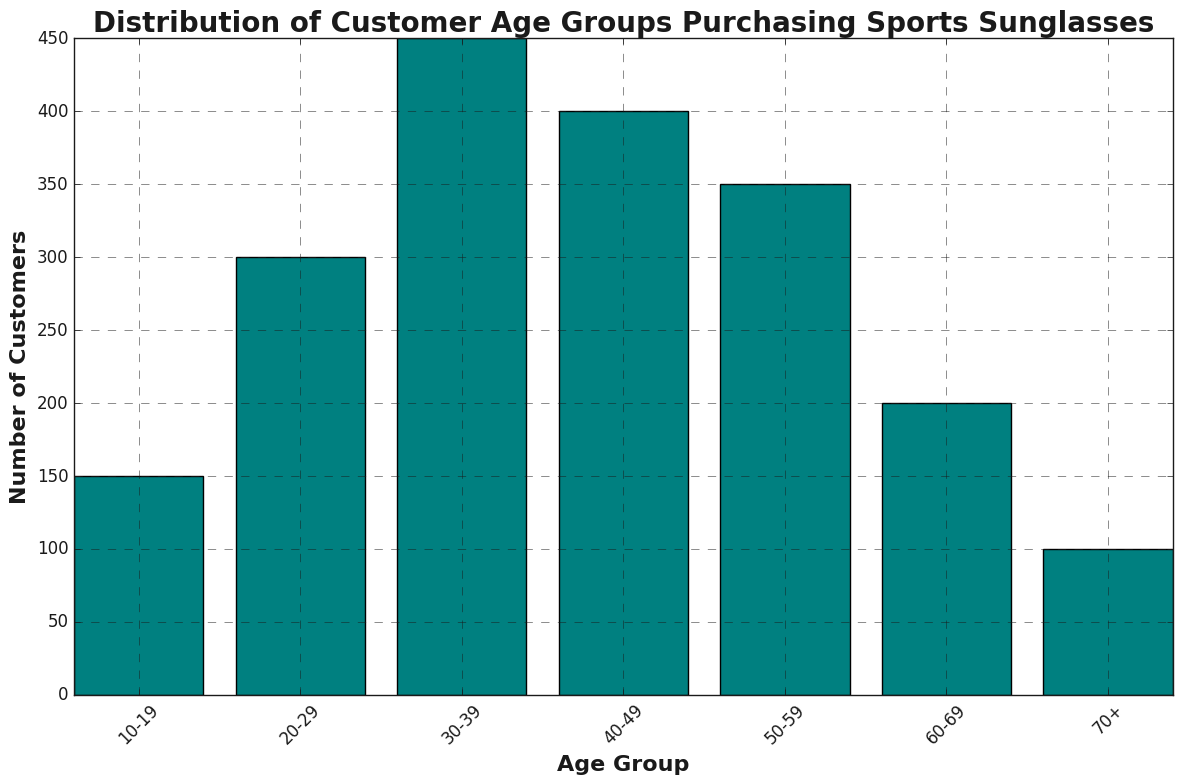What is the age group with the highest number of customers? The highest bar in the chart corresponds to the 30-39 age group, with 450 customers.
Answer: 30-39 Which age group has the lowest number of customers? The smallest bar in the chart corresponds to the 70+ age group, with 100 customers.
Answer: 70+ How many more customers are in the 30-39 age group than the 10-19 age group? The 30-39 age group has 450 customers and the 10-19 age group has 150. Subtracting 150 from 450 gives 300 more customers.
Answer: 300 What is the total number of customers in the age groups from 40-49 and 50-59 combined? The 40-49 age group has 400 customers and the 50-59 has 350 customers. Adding them gives a total of 750 customers.
Answer: 750 Which age group has more customers, 20-29 or 60-69, and by how many? The 20-29 age group has 300 customers and the 60-69 age group has 200. The difference is 300 - 200, so the 20-29 group has 100 more customers.
Answer: 20-29 by 100 What is the average number of customers across all age groups? Sum the number of customers in all age groups: 150 + 300 + 450 + 400 + 350 + 200 + 100 = 1950. There are 7 age groups, so the average is 1950 / 7 ≈ 278.57.
Answer: 278.57 Compare the bars for the age groups 10-19 and 70+. Which one is taller and by how much? The bar for the 10-19 age group is taller. The 10-19 age group has 150 customers and the 70+ age group has 100, so the difference is 150 - 100 = 50.
Answer: 10-19 by 50 What proportion of the total customers does the 50-59 age group represent? The total number of customers is 1950. The number of customers in the 50-59 age group is 350. The proportion is 350 / 1950 which is approximately 0.179 or 17.9%.
Answer: 17.9% Which age group has a customer count closest to the overall average of all age groups? The average number of customers across all age groups is approximately 278.57. The 20-29 age group has 300 customers, which is the closest to the average.
Answer: 20-29 If you combine the customers from the two highest age groups, what percentage of the total number of customers do they constitute? The two highest age groups are 30-39 (450) and 40-49 (400). Summing them gives 850. The total number of customers is 1950. The percentage is (850 / 1950) × 100 ≈ 43.59%.
Answer: 43.59% 